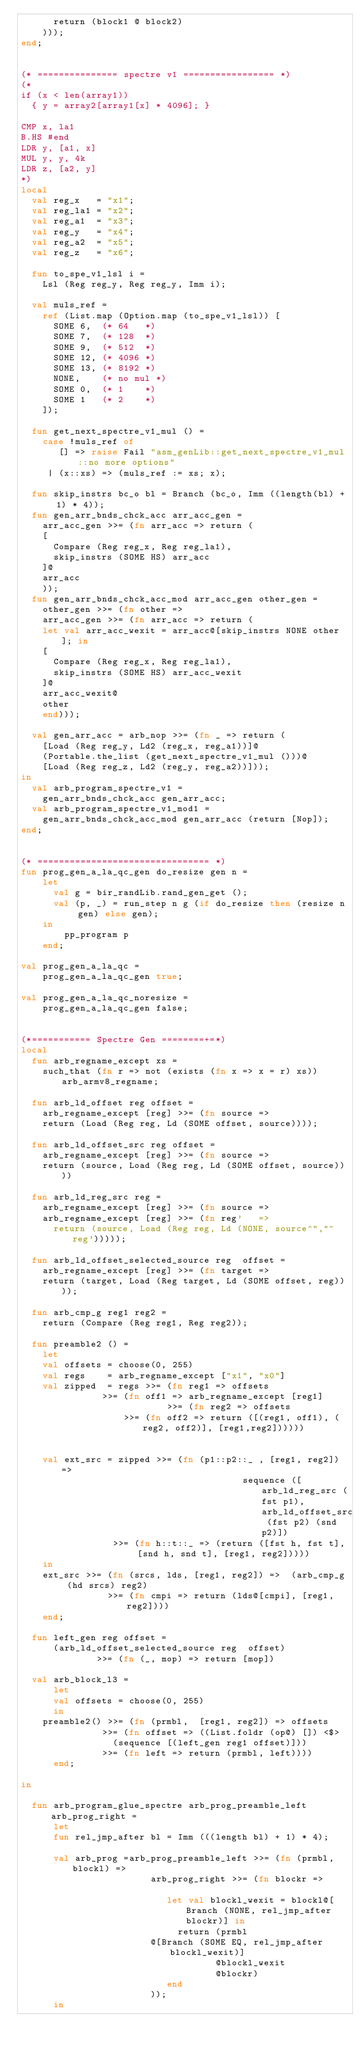Convert code to text. <code><loc_0><loc_0><loc_500><loc_500><_SML_>      return (block1 @ block2)
    )));
end;


(* =============== spectre v1 ================= *)
(*
if (x < len(array1))
  { y = array2[array1[x] * 4096]; }

CMP x, la1
B.HS #end
LDR y, [a1, x]
MUL y, y, 4k
LDR z, [a2, y]
*)
local
  val reg_x   = "x1";
  val reg_la1 = "x2";
  val reg_a1  = "x3";
  val reg_y   = "x4";
  val reg_a2  = "x5";
  val reg_z   = "x6";

  fun to_spe_v1_lsl i =
    Lsl (Reg reg_y, Reg reg_y, Imm i);

  val muls_ref =
    ref (List.map (Option.map (to_spe_v1_lsl)) [
      SOME 6,  (* 64   *)
      SOME 7,  (* 128  *)
      SOME 9,  (* 512  *)
      SOME 12, (* 4096 *)
      SOME 13, (* 8192 *)
      NONE,    (* no mul *)
      SOME 0,  (* 1    *)
      SOME 1   (* 2    *)
    ]);

  fun get_next_spectre_v1_mul () =
    case !muls_ref of
       [] => raise Fail "asm_genLib::get_next_spectre_v1_mul::no more options"
     | (x::xs) => (muls_ref := xs; x);

  fun skip_instrs bc_o bl = Branch (bc_o, Imm ((length(bl) + 1) * 4));
  fun gen_arr_bnds_chck_acc arr_acc_gen =
    arr_acc_gen >>= (fn arr_acc => return (
    [
      Compare (Reg reg_x, Reg reg_la1),
      skip_instrs (SOME HS) arr_acc
    ]@
    arr_acc
    ));
  fun gen_arr_bnds_chck_acc_mod arr_acc_gen other_gen =
    other_gen >>= (fn other =>
    arr_acc_gen >>= (fn arr_acc => return (
    let val arr_acc_wexit = arr_acc@[skip_instrs NONE other]; in
    [
      Compare (Reg reg_x, Reg reg_la1),
      skip_instrs (SOME HS) arr_acc_wexit
    ]@
    arr_acc_wexit@
    other
    end)));

  val gen_arr_acc = arb_nop >>= (fn _ => return (
    [Load (Reg reg_y, Ld2 (reg_x, reg_a1))]@
    (Portable.the_list (get_next_spectre_v1_mul ()))@
    [Load (Reg reg_z, Ld2 (reg_y, reg_a2))]));
in
  val arb_program_spectre_v1 =
    gen_arr_bnds_chck_acc gen_arr_acc;
  val arb_program_spectre_v1_mod1 =
    gen_arr_bnds_chck_acc_mod gen_arr_acc (return [Nop]);
end;


(* ================================ *)
fun prog_gen_a_la_qc_gen do_resize gen n =
    let
      val g = bir_randLib.rand_gen_get ();
      val (p, _) = run_step n g (if do_resize then (resize n gen) else gen);
    in
        pp_program p
    end;

val prog_gen_a_la_qc =
    prog_gen_a_la_qc_gen true;

val prog_gen_a_la_qc_noresize =
    prog_gen_a_la_qc_gen false;


(*=========== Spectre Gen ========+=*)
local
  fun arb_regname_except xs =
    such_that (fn r => not (exists (fn x => x = r) xs)) arb_armv8_regname;

  fun arb_ld_offset reg offset =
    arb_regname_except [reg] >>= (fn source =>
    return (Load (Reg reg, Ld (SOME offset, source))));

  fun arb_ld_offset_src reg offset =
    arb_regname_except [reg] >>= (fn source => 
    return (source, Load (Reg reg, Ld (SOME offset, source))))

  fun arb_ld_reg_src reg =
    arb_regname_except [reg] >>= (fn source => 
    arb_regname_except [reg] >>= (fn reg'   =>
      return (source, Load (Reg reg, Ld (NONE, source^","^reg')))));

  fun arb_ld_offset_selected_source reg  offset =
    arb_regname_except [reg] >>= (fn target =>
    return (target, Load (Reg target, Ld (SOME offset, reg))));

  fun arb_cmp_g reg1 reg2 =
    return (Compare (Reg reg1, Reg reg2));

  fun preamble2 () =
    let
	val offsets = choose(0, 255)
	val regs    = arb_regname_except ["x1", "x0"]
	val zipped  = regs >>= (fn reg1 => offsets 
			   >>= (fn off1 => arb_regname_except [reg1]
                           >>= (fn reg2 => offsets
		           >>= (fn off2 => return ([(reg1, off1), (reg2, off2)], [reg1,reg2])))))


	val ext_src = zipped >>= (fn (p1::p2::_ , [reg1, reg2]) =>
                                         sequence ([arb_ld_reg_src (fst p1), arb_ld_offset_src (fst p2) (snd p2)])
			     >>= (fn h::t::_ => (return ([fst h, fst t], [snd h, snd t], [reg1, reg2]))))
    in
	ext_src >>= (fn (srcs, lds, [reg1, reg2]) =>  (arb_cmp_g (hd srcs) reg2)
                >>= (fn cmpi => return (lds@[cmpi], [reg1, reg2])))
    end;

  fun left_gen reg offset =
      (arb_ld_offset_selected_source reg  offset)
              >>= (fn (_, mop) => return [mop])
      
  val arb_block_l3 = 
      let 
	  val offsets = choose(0, 255)
      in
    preamble2() >>= (fn (prmbl,  [reg1, reg2]) => offsets 
               >>= (fn offset => ((List.foldr (op@) []) <$> 
   	             (sequence [(left_gen reg1 offset)]))
               >>= (fn left => return (prmbl, left))))
      end;

in

  fun arb_program_glue_spectre arb_prog_preamble_left arb_prog_right =
      let
  	  fun rel_jmp_after bl = Imm (((length bl) + 1) * 4);

  	  val arb_prog =arb_prog_preamble_left >>= (fn (prmbl, blockl) =>
                        arb_prog_right >>= (fn blockr =>
            
                           let val blockl_wexit = blockl@[Branch (NONE, rel_jmp_after blockr)] in
                             return (prmbl
  			            @[Branch (SOME EQ, rel_jmp_after blockl_wexit)]
                                    @blockl_wexit
                                    @blockr)
                           end
                        ));
      in</code> 